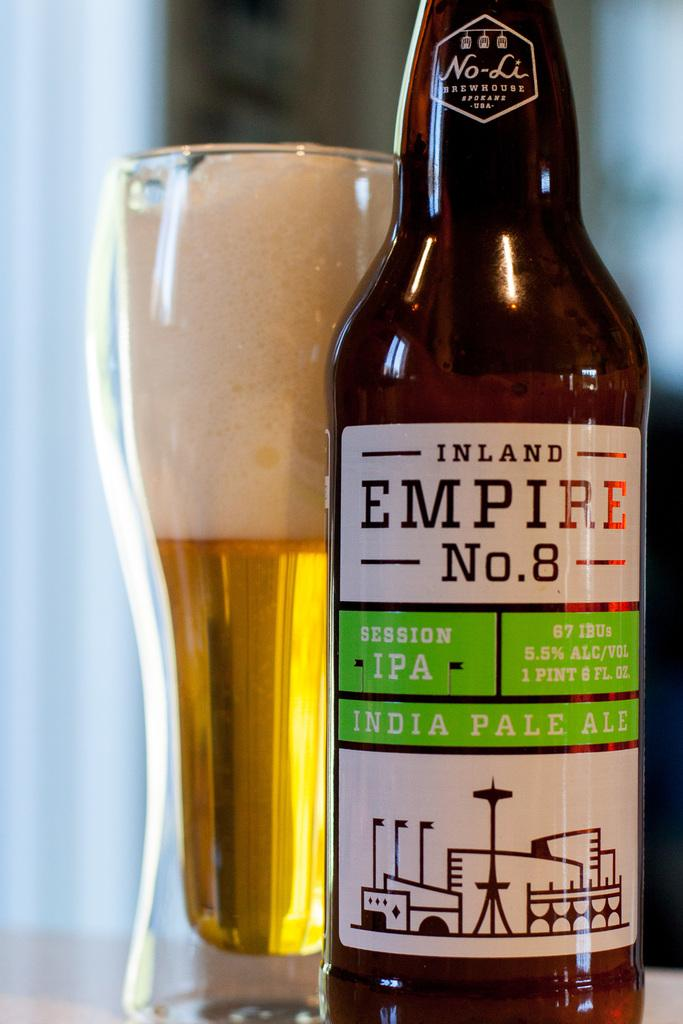<image>
Share a concise interpretation of the image provided. A glass of beer stands next to a bottle of India Pale Ale. 